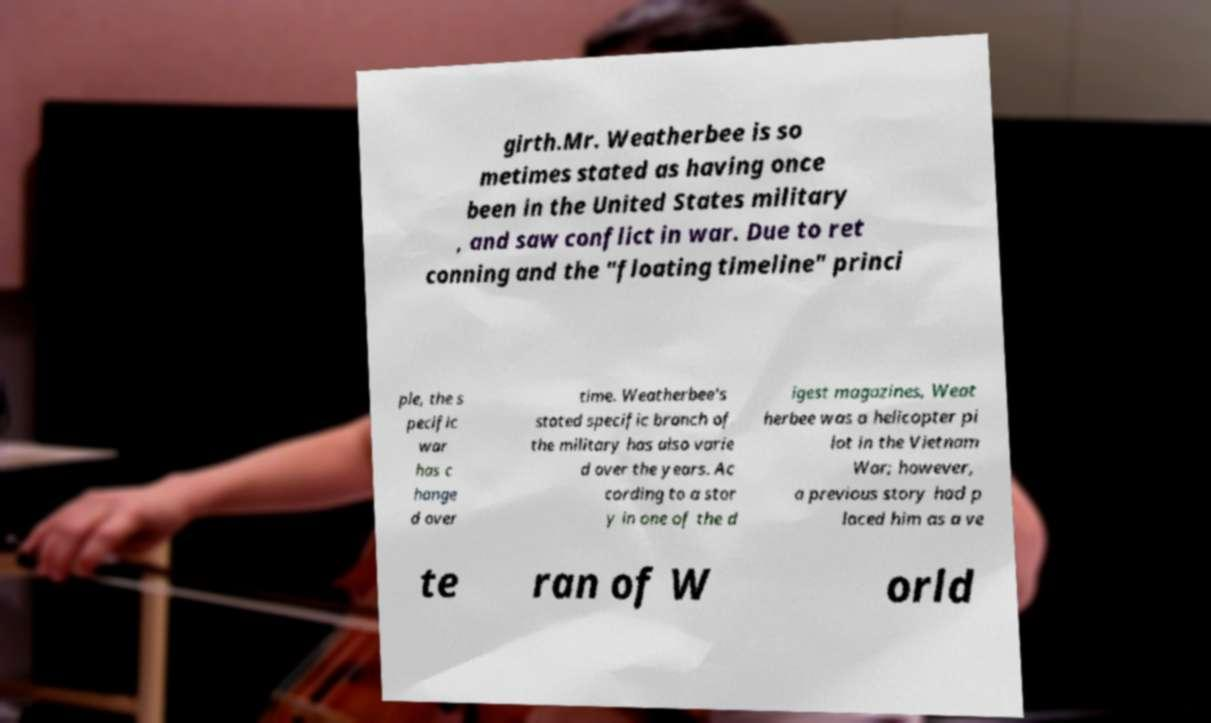Please identify and transcribe the text found in this image. girth.Mr. Weatherbee is so metimes stated as having once been in the United States military , and saw conflict in war. Due to ret conning and the "floating timeline" princi ple, the s pecific war has c hange d over time. Weatherbee's stated specific branch of the military has also varie d over the years. Ac cording to a stor y in one of the d igest magazines, Weat herbee was a helicopter pi lot in the Vietnam War; however, a previous story had p laced him as a ve te ran of W orld 